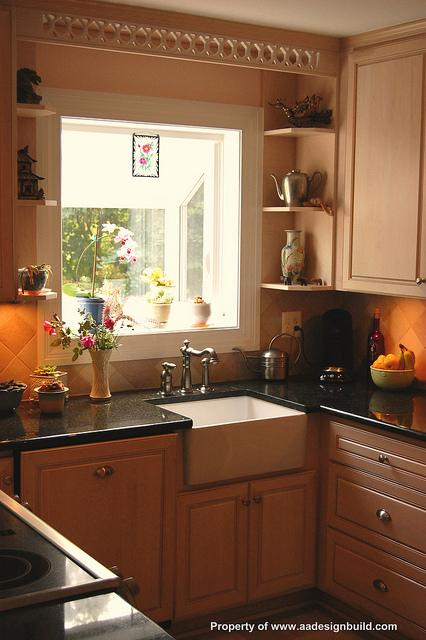What type of animals are shown on the lowest shelf to the right of the sink? cat 